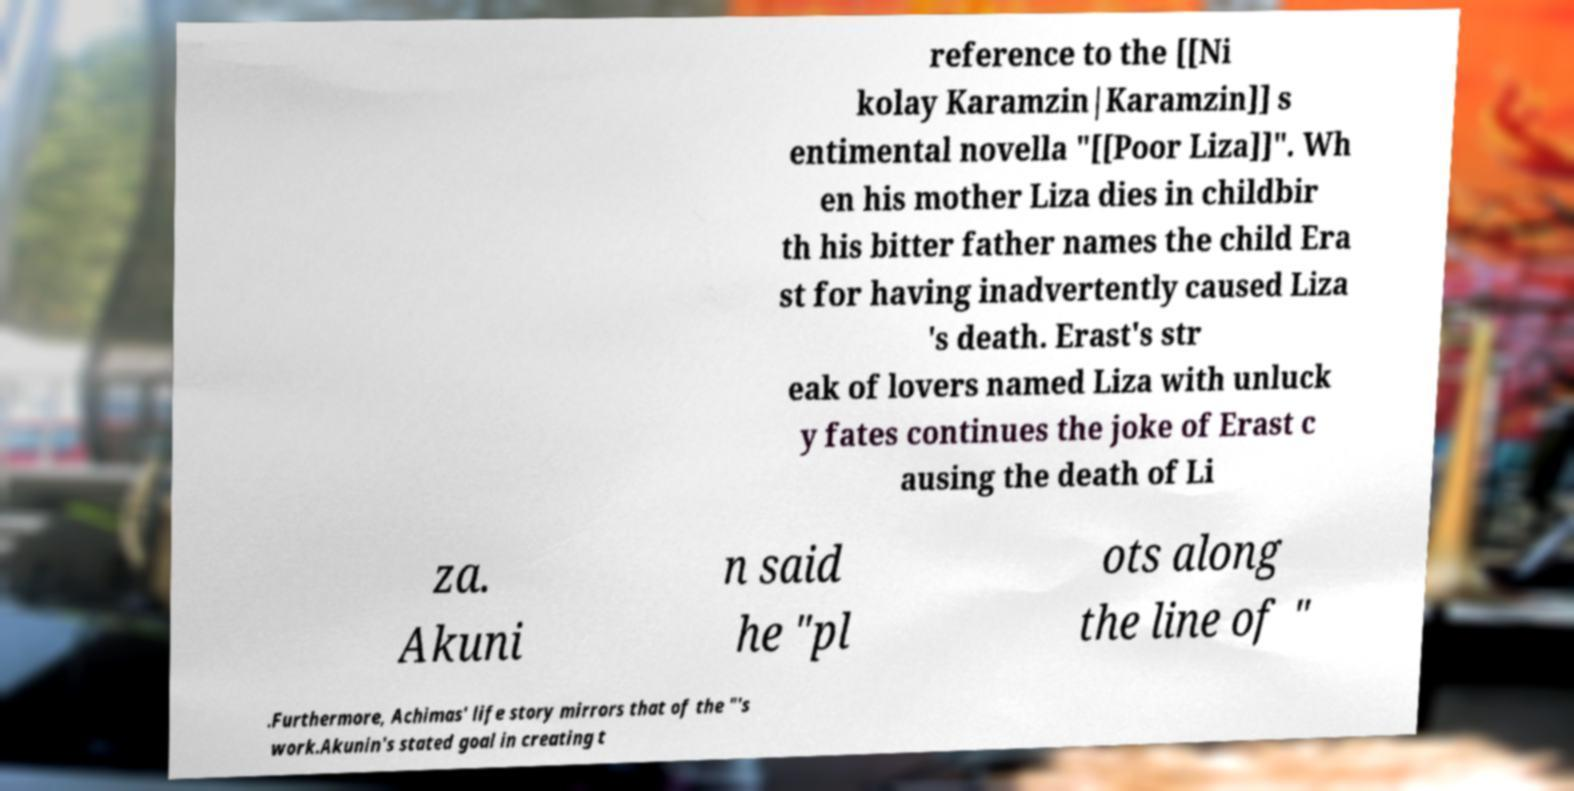I need the written content from this picture converted into text. Can you do that? reference to the [[Ni kolay Karamzin|Karamzin]] s entimental novella "[[Poor Liza]]". Wh en his mother Liza dies in childbir th his bitter father names the child Era st for having inadvertently caused Liza 's death. Erast's str eak of lovers named Liza with unluck y fates continues the joke of Erast c ausing the death of Li za. Akuni n said he "pl ots along the line of " .Furthermore, Achimas' life story mirrors that of the "'s work.Akunin's stated goal in creating t 